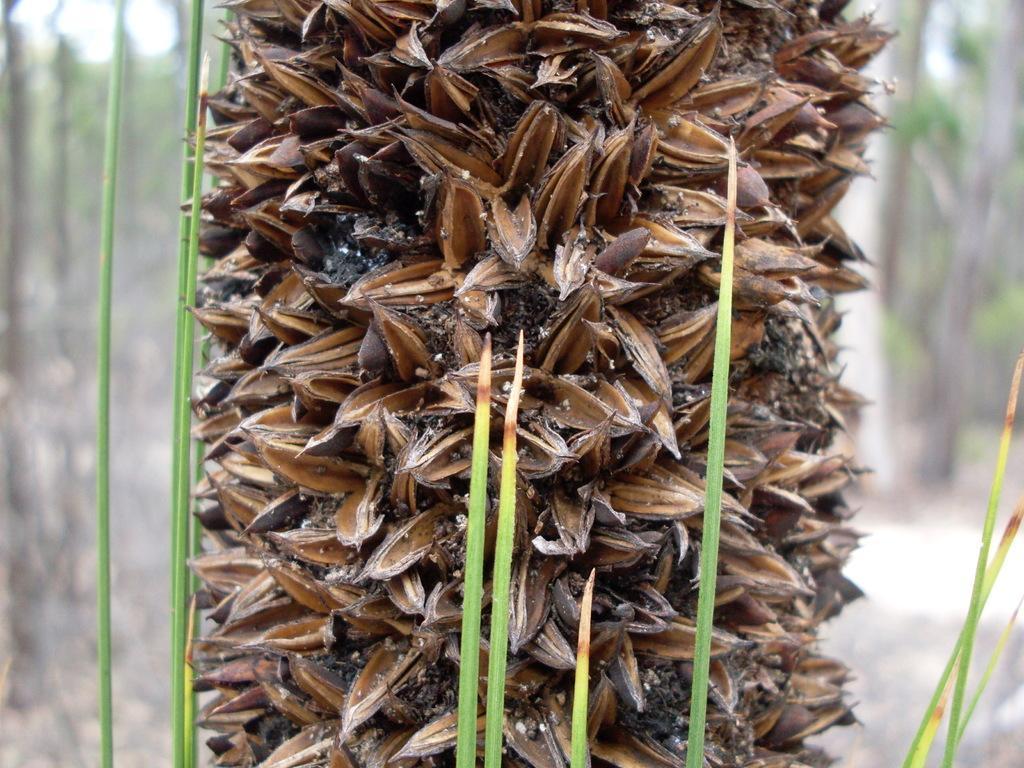In one or two sentences, can you explain what this image depicts? In this image there is a tree and grass. 